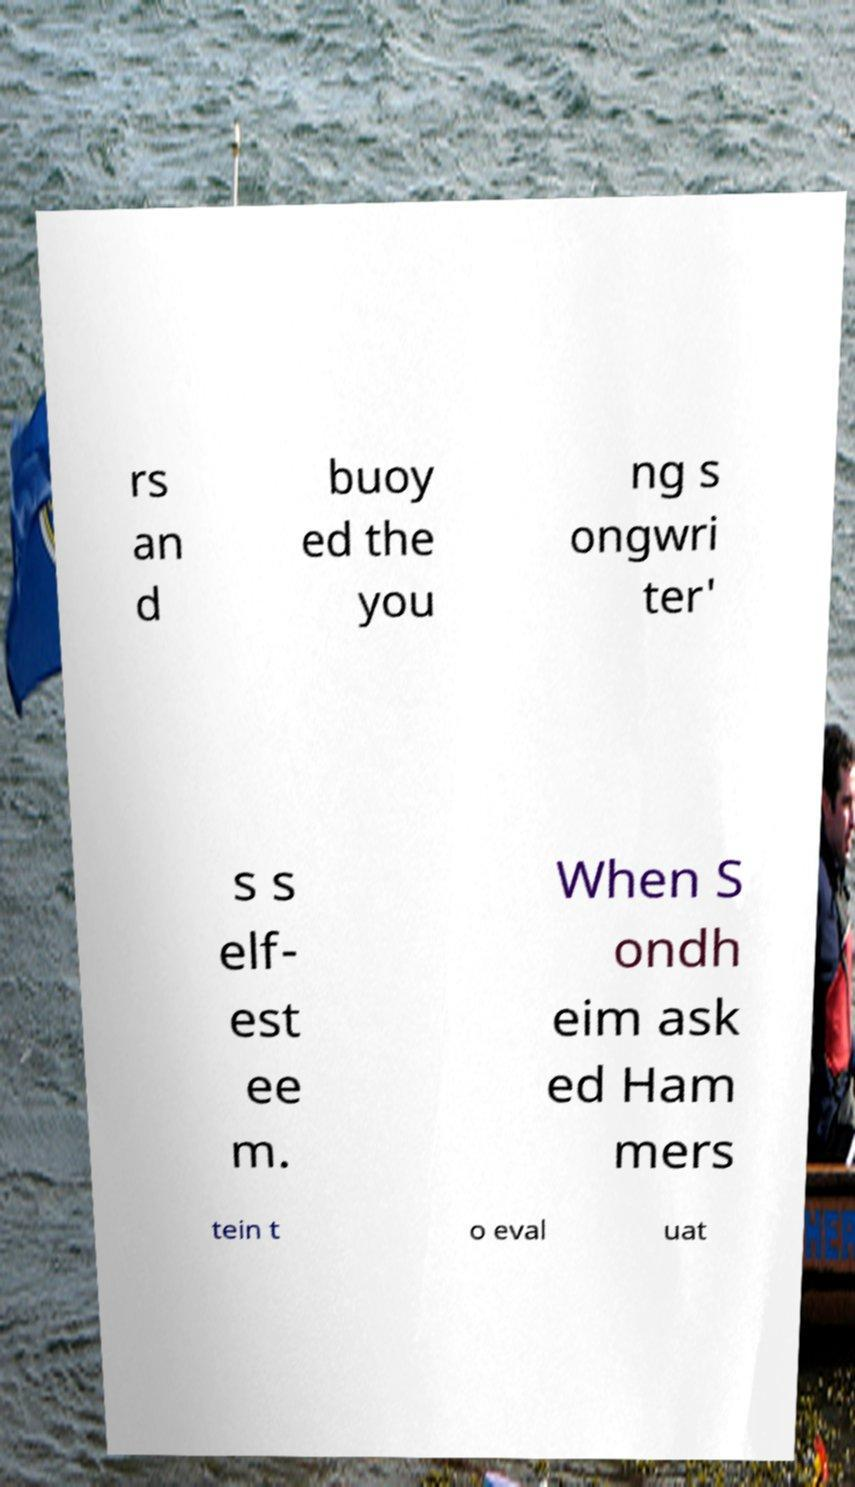Please read and relay the text visible in this image. What does it say? rs an d buoy ed the you ng s ongwri ter' s s elf- est ee m. When S ondh eim ask ed Ham mers tein t o eval uat 